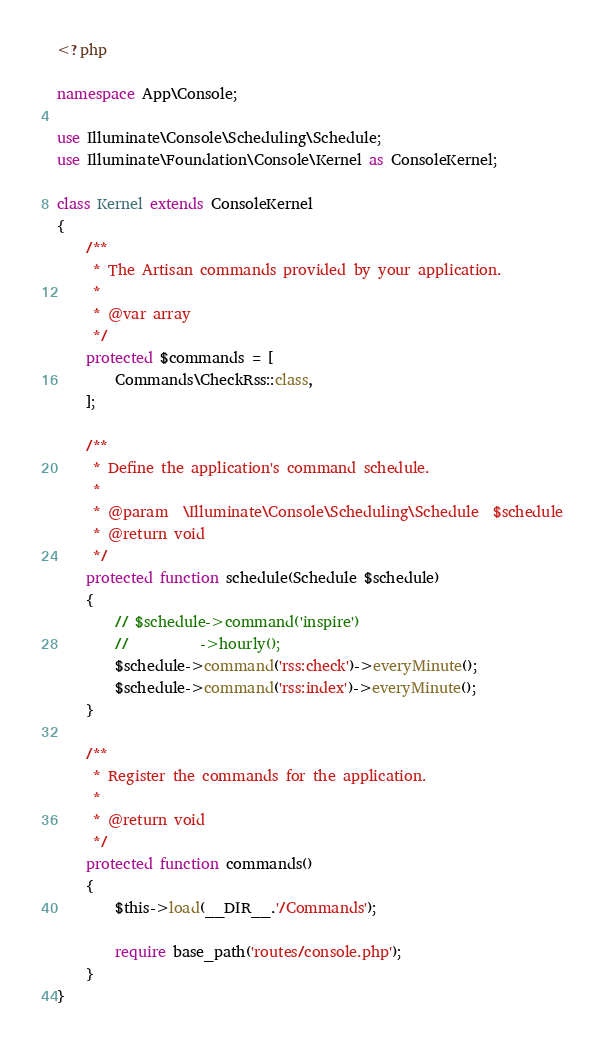Convert code to text. <code><loc_0><loc_0><loc_500><loc_500><_PHP_><?php

namespace App\Console;

use Illuminate\Console\Scheduling\Schedule;
use Illuminate\Foundation\Console\Kernel as ConsoleKernel;

class Kernel extends ConsoleKernel
{
    /**
     * The Artisan commands provided by your application.
     *
     * @var array
     */
    protected $commands = [
        Commands\CheckRss::class,
    ];

    /**
     * Define the application's command schedule.
     *
     * @param  \Illuminate\Console\Scheduling\Schedule  $schedule
     * @return void
     */
    protected function schedule(Schedule $schedule)
    {
        // $schedule->command('inspire')
        //          ->hourly();
        $schedule->command('rss:check')->everyMinute();
        $schedule->command('rss:index')->everyMinute();
    }

    /**
     * Register the commands for the application.
     *
     * @return void
     */
    protected function commands()
    {
        $this->load(__DIR__.'/Commands');

        require base_path('routes/console.php');
    }
}
</code> 